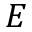<formula> <loc_0><loc_0><loc_500><loc_500>E</formula> 